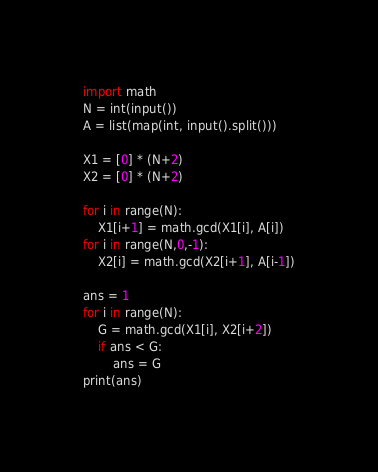<code> <loc_0><loc_0><loc_500><loc_500><_Python_>import math
N = int(input())
A = list(map(int, input().split()))

X1 = [0] * (N+2)
X2 = [0] * (N+2)

for i in range(N):
    X1[i+1] = math.gcd(X1[i], A[i])
for i in range(N,0,-1):
    X2[i] = math.gcd(X2[i+1], A[i-1])

ans = 1
for i in range(N):
    G = math.gcd(X1[i], X2[i+2])
    if ans < G:
        ans = G
print(ans)</code> 